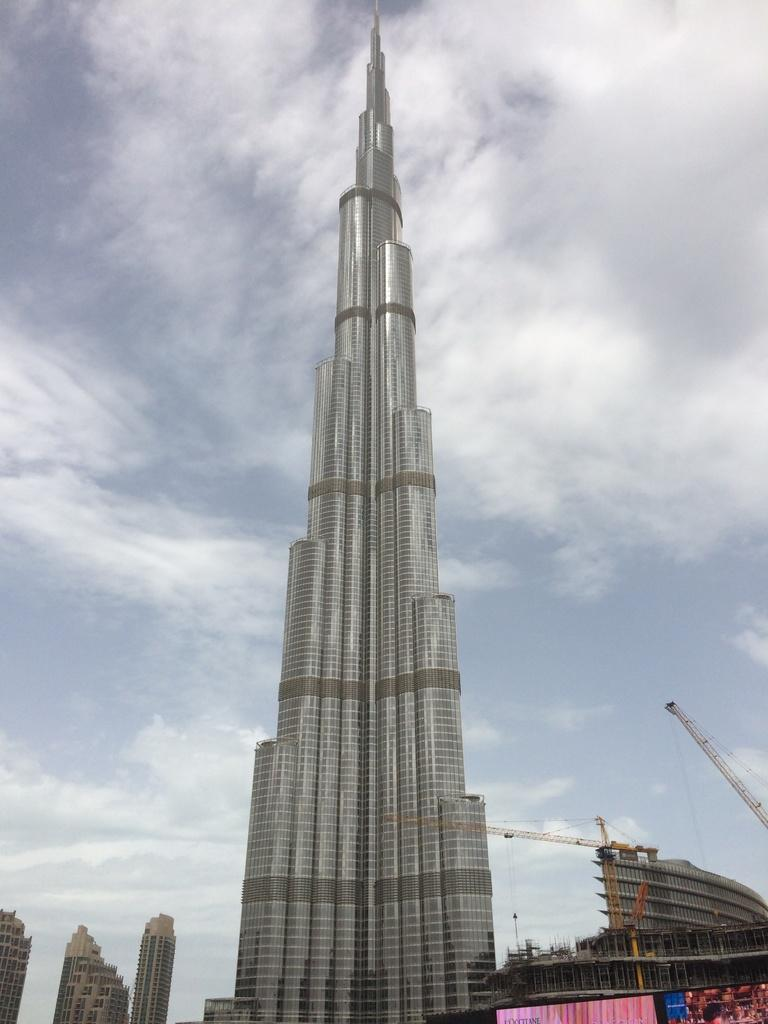What is located in the center of the image? There are buildings, a screen, and a tower in the center of the image. What can be seen in the background of the image? The sky is visible in the background of the image, and clouds are present. Can you describe the tower in the image? The tower is located in the center of the image, but there is no additional information provided about its appearance or features. What type of baseball game is being played on the screen in the image? There is no baseball game present on the screen in the image. Who is the guide leading through the buildings in the image? There is no guide or indication of a guided tour in the image. 